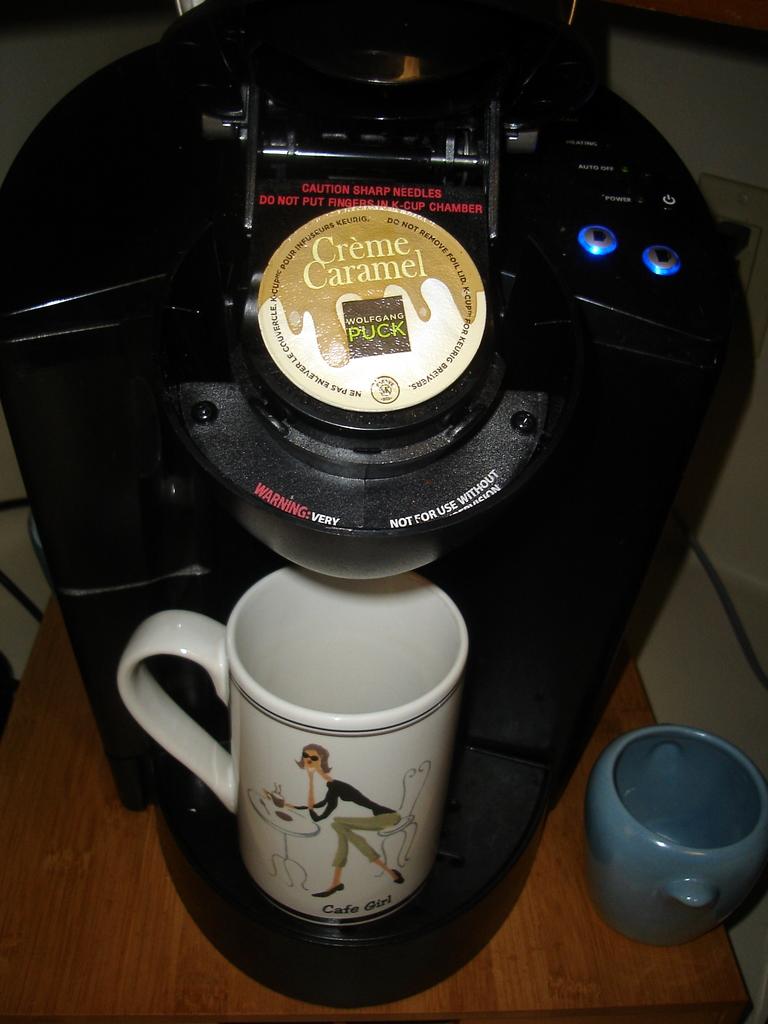What flavor is the coffee pod?
Provide a short and direct response. Creme caramel. What does the coffee mug say?
Your answer should be very brief. Cafe girl. 